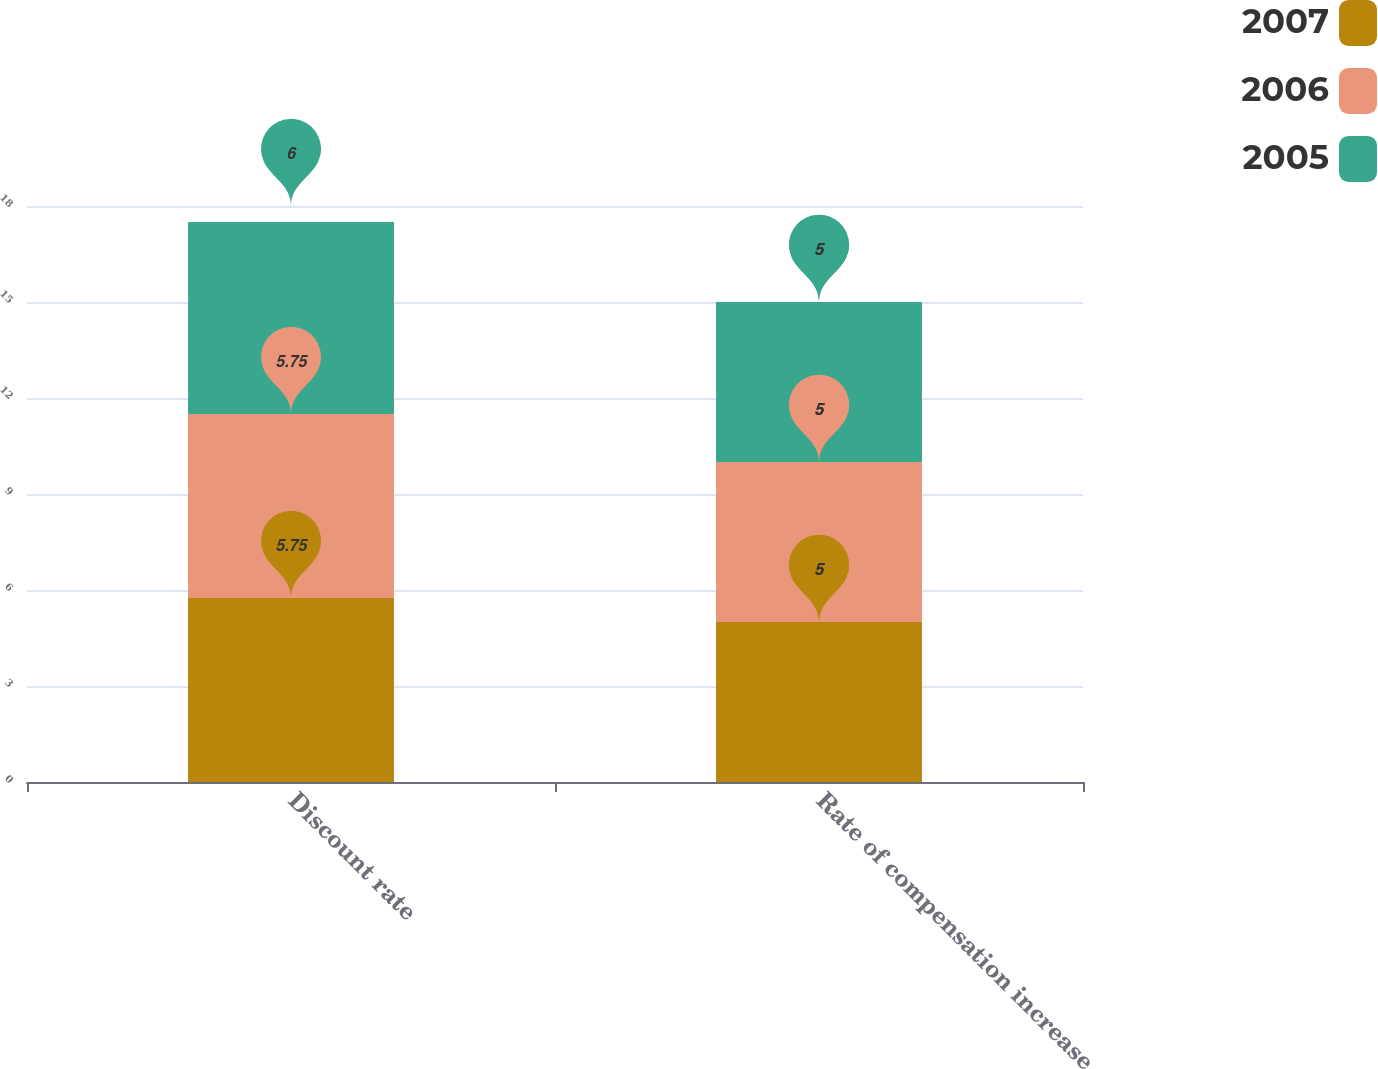<chart> <loc_0><loc_0><loc_500><loc_500><stacked_bar_chart><ecel><fcel>Discount rate<fcel>Rate of compensation increase<nl><fcel>2007<fcel>5.75<fcel>5<nl><fcel>2006<fcel>5.75<fcel>5<nl><fcel>2005<fcel>6<fcel>5<nl></chart> 